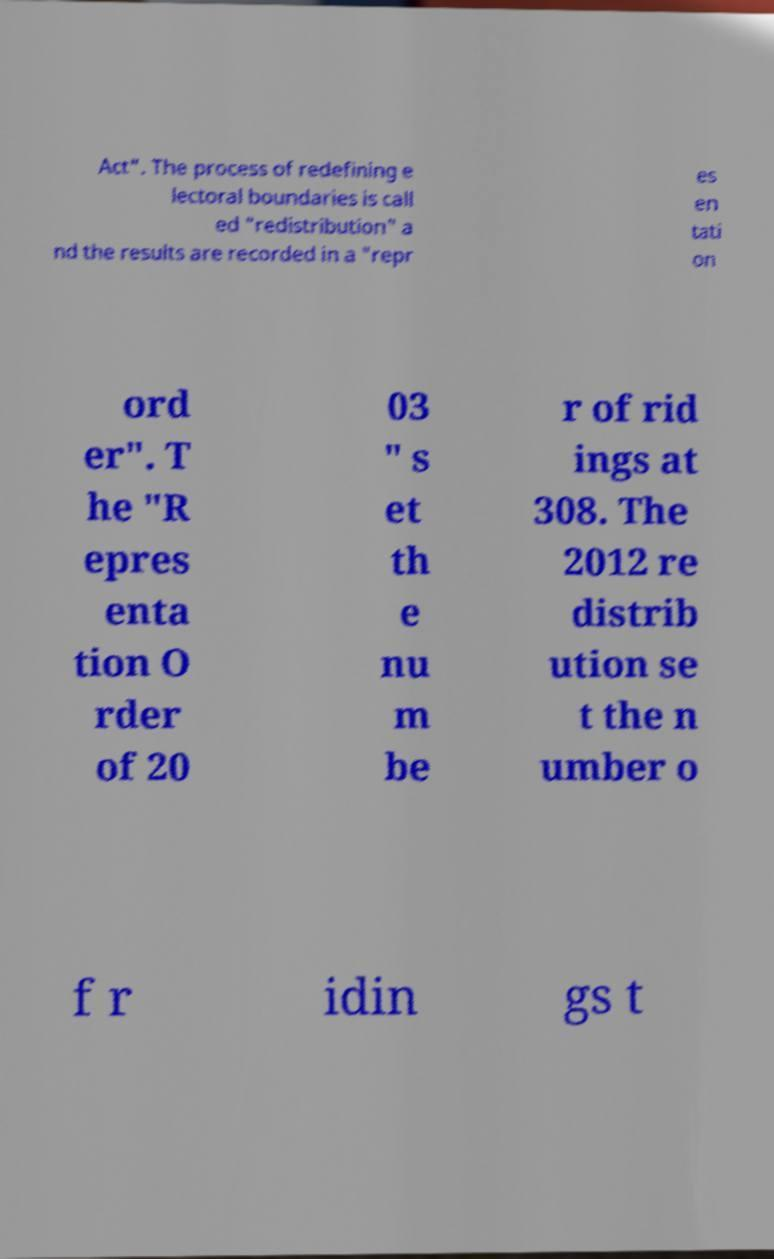Can you accurately transcribe the text from the provided image for me? Act". The process of redefining e lectoral boundaries is call ed "redistribution" a nd the results are recorded in a "repr es en tati on ord er". T he "R epres enta tion O rder of 20 03 " s et th e nu m be r of rid ings at 308. The 2012 re distrib ution se t the n umber o f r idin gs t 